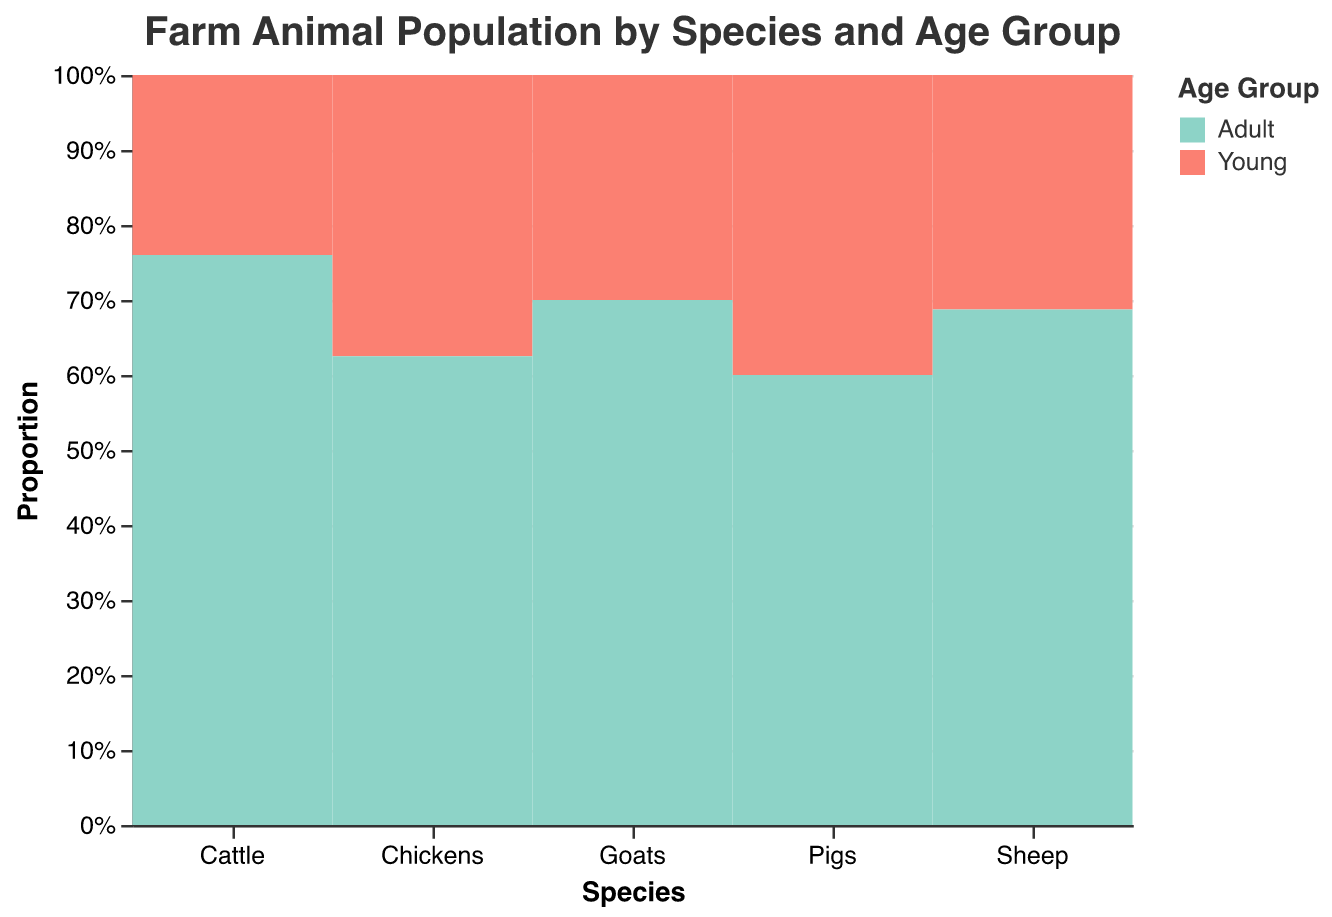what is the title of the figure? The title of the figure is shown at the top and it reads “Farm Animal Population by Species and Age Group.”
Answer: Farm Animal Population by Species and Age Group Which species has the largest adult population? By looking at the bars representing the adult population for each species, Chickens have the largest proportion of adult population compared to others.
Answer: Chickens What is the population of young goats? From the tooltip data shown when hovering over the bar for young goats, the population is displayed.
Answer: 300 Which age group has a larger population for cattle, young or adult? By comparing the heights of the bars for cattle, the adult cattle bar is taller, indicating a larger population.
Answer: Adult What percentage of the total chicken population is young? The bar representing young chickens has a height representing a smaller proportion compared to the adult chickens. The young bar is approximately a third of the total, indicating about 37.5%.
Answer: 37.5% How does the population of young pigs compare to young sheep? The bar for young sheep is significantly taller than that for young pigs, indicating a larger population for young sheep.
Answer: Young sheep population is larger What is the population difference between adult and young goats? The population of adult goats is 700, while that of young goats is 300. The difference is 700 - 300 = 400.
Answer: 400 Which species has almost similar populations between young and adult age groups? Pigs have almost similar-sized bars for young and adult age groups, indicating nearly equal populations.
Answer: Pigs Are there more young cattle or young pigs? By comparing the bars for young cattle and young pigs, the young cattle bar is taller.
Answer: Young cattle Which species has the smallest young population? By observing the shortest bar for the young age group, goats have the smallest young population.
Answer: Goats 